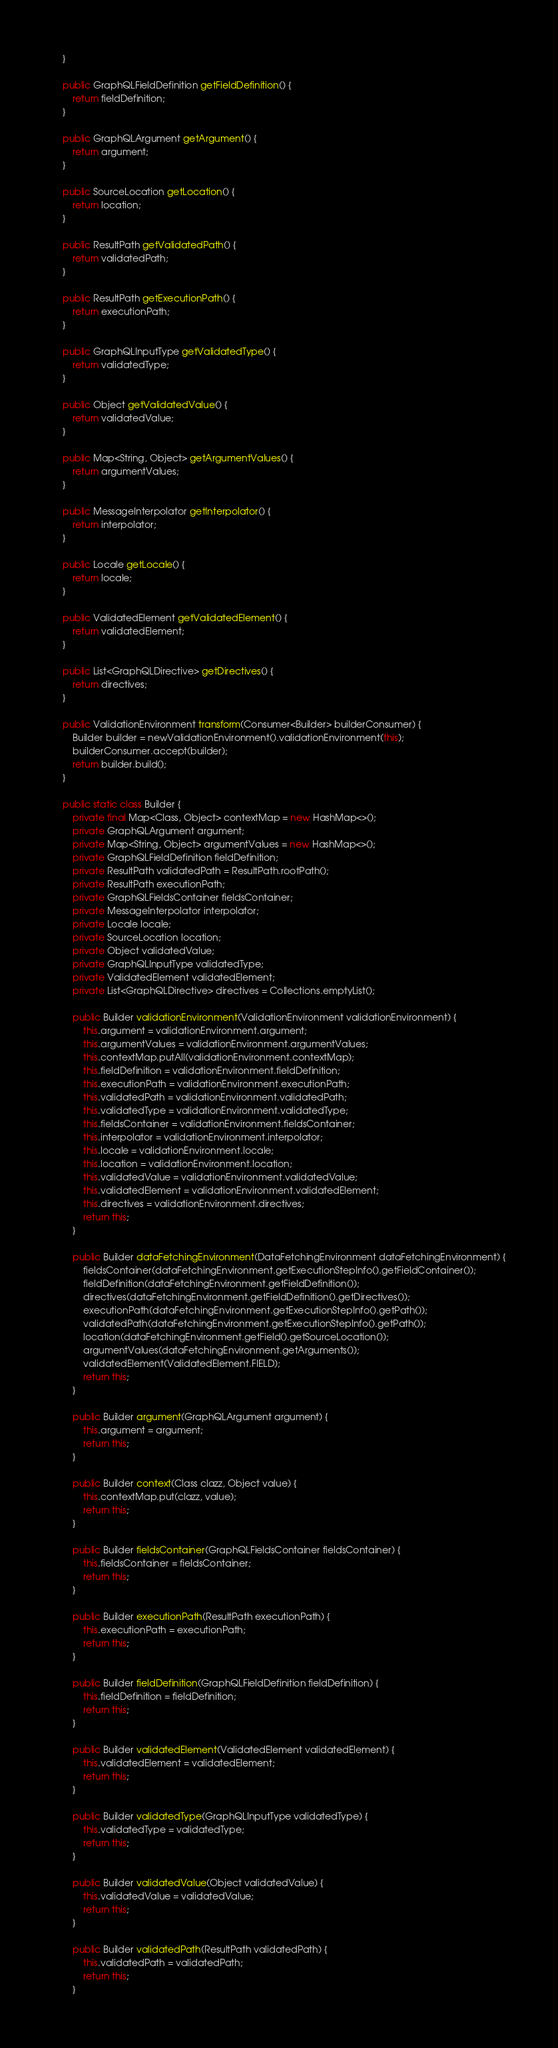Convert code to text. <code><loc_0><loc_0><loc_500><loc_500><_Java_>    }

    public GraphQLFieldDefinition getFieldDefinition() {
        return fieldDefinition;
    }

    public GraphQLArgument getArgument() {
        return argument;
    }

    public SourceLocation getLocation() {
        return location;
    }

    public ResultPath getValidatedPath() {
        return validatedPath;
    }

    public ResultPath getExecutionPath() {
        return executionPath;
    }

    public GraphQLInputType getValidatedType() {
        return validatedType;
    }

    public Object getValidatedValue() {
        return validatedValue;
    }

    public Map<String, Object> getArgumentValues() {
        return argumentValues;
    }

    public MessageInterpolator getInterpolator() {
        return interpolator;
    }

    public Locale getLocale() {
        return locale;
    }

    public ValidatedElement getValidatedElement() {
        return validatedElement;
    }

    public List<GraphQLDirective> getDirectives() {
        return directives;
    }

    public ValidationEnvironment transform(Consumer<Builder> builderConsumer) {
        Builder builder = newValidationEnvironment().validationEnvironment(this);
        builderConsumer.accept(builder);
        return builder.build();
    }

    public static class Builder {
        private final Map<Class, Object> contextMap = new HashMap<>();
        private GraphQLArgument argument;
        private Map<String, Object> argumentValues = new HashMap<>();
        private GraphQLFieldDefinition fieldDefinition;
        private ResultPath validatedPath = ResultPath.rootPath();
        private ResultPath executionPath;
        private GraphQLFieldsContainer fieldsContainer;
        private MessageInterpolator interpolator;
        private Locale locale;
        private SourceLocation location;
        private Object validatedValue;
        private GraphQLInputType validatedType;
        private ValidatedElement validatedElement;
        private List<GraphQLDirective> directives = Collections.emptyList();

        public Builder validationEnvironment(ValidationEnvironment validationEnvironment) {
            this.argument = validationEnvironment.argument;
            this.argumentValues = validationEnvironment.argumentValues;
            this.contextMap.putAll(validationEnvironment.contextMap);
            this.fieldDefinition = validationEnvironment.fieldDefinition;
            this.executionPath = validationEnvironment.executionPath;
            this.validatedPath = validationEnvironment.validatedPath;
            this.validatedType = validationEnvironment.validatedType;
            this.fieldsContainer = validationEnvironment.fieldsContainer;
            this.interpolator = validationEnvironment.interpolator;
            this.locale = validationEnvironment.locale;
            this.location = validationEnvironment.location;
            this.validatedValue = validationEnvironment.validatedValue;
            this.validatedElement = validationEnvironment.validatedElement;
            this.directives = validationEnvironment.directives;
            return this;
        }

        public Builder dataFetchingEnvironment(DataFetchingEnvironment dataFetchingEnvironment) {
            fieldsContainer(dataFetchingEnvironment.getExecutionStepInfo().getFieldContainer());
            fieldDefinition(dataFetchingEnvironment.getFieldDefinition());
            directives(dataFetchingEnvironment.getFieldDefinition().getDirectives());
            executionPath(dataFetchingEnvironment.getExecutionStepInfo().getPath());
            validatedPath(dataFetchingEnvironment.getExecutionStepInfo().getPath());
            location(dataFetchingEnvironment.getField().getSourceLocation());
            argumentValues(dataFetchingEnvironment.getArguments());
            validatedElement(ValidatedElement.FIELD);
            return this;
        }

        public Builder argument(GraphQLArgument argument) {
            this.argument = argument;
            return this;
        }

        public Builder context(Class clazz, Object value) {
            this.contextMap.put(clazz, value);
            return this;
        }

        public Builder fieldsContainer(GraphQLFieldsContainer fieldsContainer) {
            this.fieldsContainer = fieldsContainer;
            return this;
        }

        public Builder executionPath(ResultPath executionPath) {
            this.executionPath = executionPath;
            return this;
        }

        public Builder fieldDefinition(GraphQLFieldDefinition fieldDefinition) {
            this.fieldDefinition = fieldDefinition;
            return this;
        }

        public Builder validatedElement(ValidatedElement validatedElement) {
            this.validatedElement = validatedElement;
            return this;
        }

        public Builder validatedType(GraphQLInputType validatedType) {
            this.validatedType = validatedType;
            return this;
        }

        public Builder validatedValue(Object validatedValue) {
            this.validatedValue = validatedValue;
            return this;
        }

        public Builder validatedPath(ResultPath validatedPath) {
            this.validatedPath = validatedPath;
            return this;
        }
</code> 